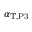<formula> <loc_0><loc_0><loc_500><loc_500>\alpha _ { T , P 3 }</formula> 